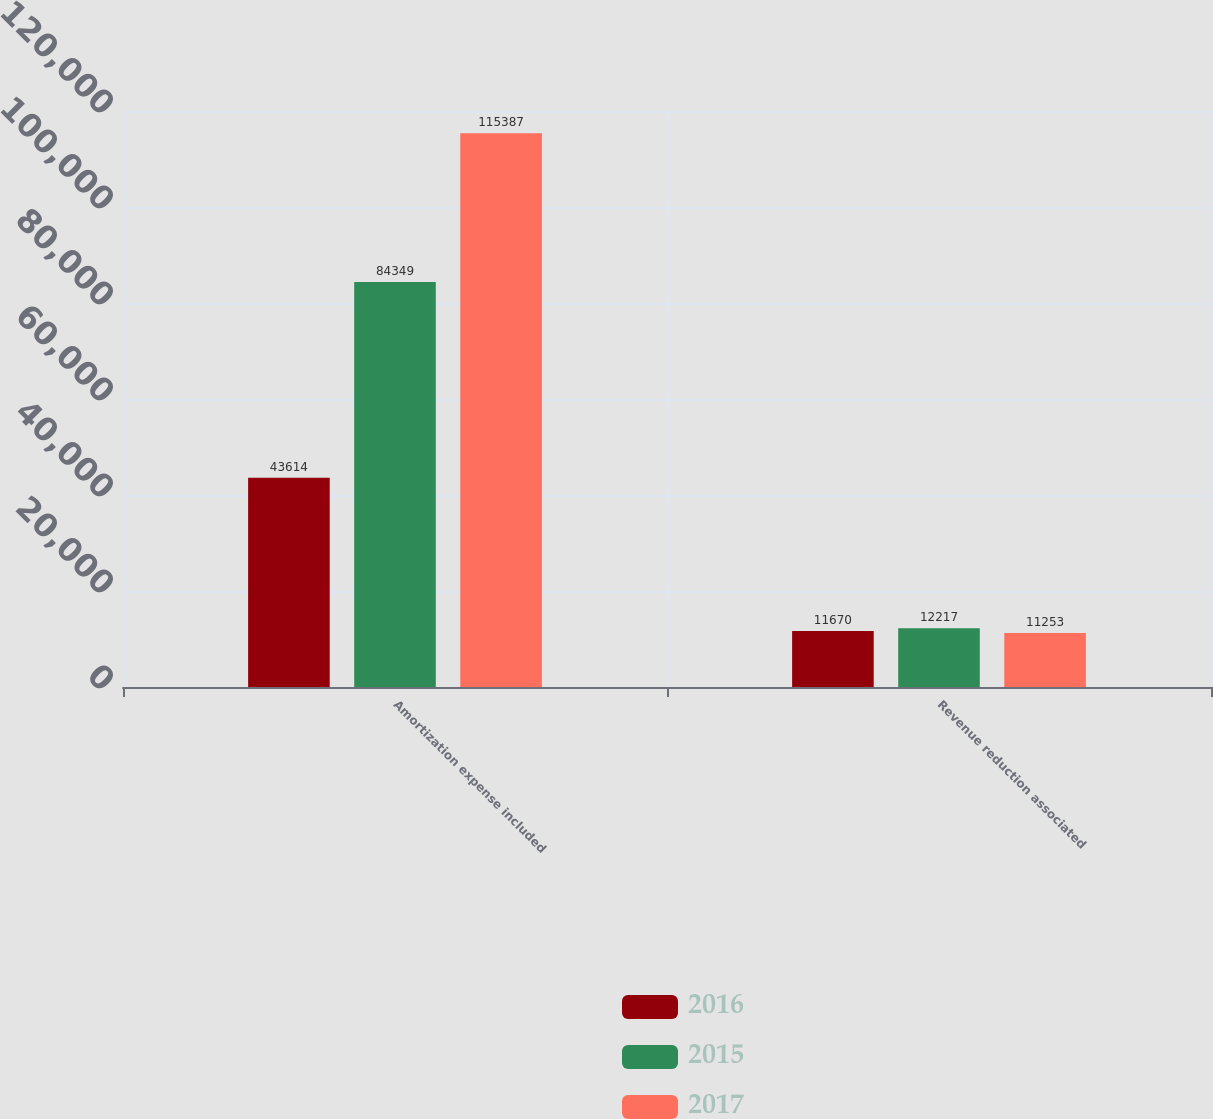Convert chart. <chart><loc_0><loc_0><loc_500><loc_500><stacked_bar_chart><ecel><fcel>Amortization expense included<fcel>Revenue reduction associated<nl><fcel>2016<fcel>43614<fcel>11670<nl><fcel>2015<fcel>84349<fcel>12217<nl><fcel>2017<fcel>115387<fcel>11253<nl></chart> 